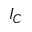<formula> <loc_0><loc_0><loc_500><loc_500>I _ { C }</formula> 